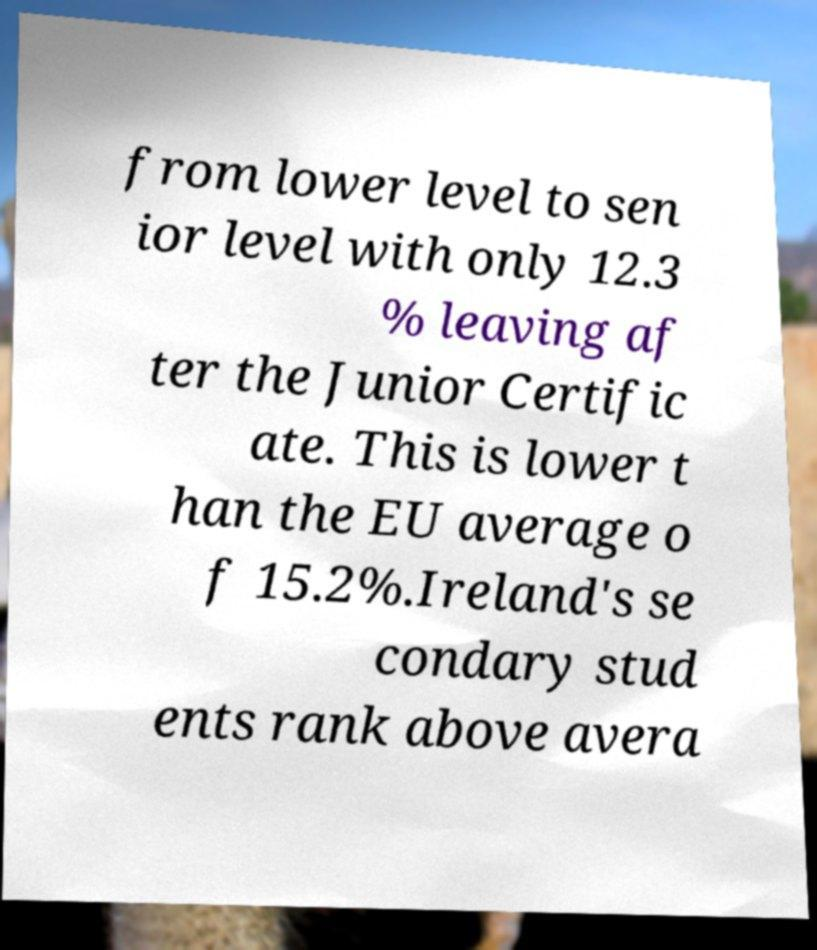Could you extract and type out the text from this image? from lower level to sen ior level with only 12.3 % leaving af ter the Junior Certific ate. This is lower t han the EU average o f 15.2%.Ireland's se condary stud ents rank above avera 